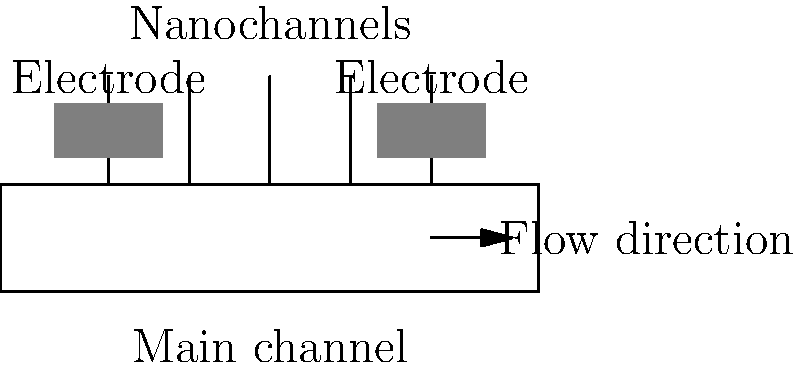In the nanofluidic energy harvesting system shown above, what is the primary purpose of the nanochannels connecting the main channel to the electrodes? To understand the purpose of the nanochannels in this nanofluidic energy harvesting system, let's break down the components and their functions:

1. Main channel: This is where the bulk fluid flows through the system.

2. Nanochannels: These are the small channels connecting the main channel to the electrodes.

3. Electrodes: These are the components that collect the generated electrical energy.

The primary purpose of the nanochannels is related to the phenomenon known as streaming potential or electrokinetic effect. Here's how it works:

1. As the fluid flows through the main channel, it creates a pressure difference across the nanochannels.

2. This pressure difference drives a portion of the fluid through the nanochannels.

3. The nanochannels have a very small diameter, typically on the order of nanometers. At this scale, the electric double layer (EDL) formed at the solid-liquid interface becomes significant.

4. As the fluid is forced through the nanochannels, it causes a separation of charges in the EDL, with counter-ions being dragged along with the flow.

5. This charge separation creates a potential difference between the ends of the nanochannels, known as the streaming potential.

6. The electrodes at the ends of the nanochannels collect this potential difference, which can be harnessed as electrical energy.

Therefore, the primary purpose of the nanochannels is to facilitate the generation of a streaming potential by exploiting the electrokinetic effects at the nanoscale, converting the mechanical energy of fluid flow into electrical energy.
Answer: To generate streaming potential through electrokinetic effects 